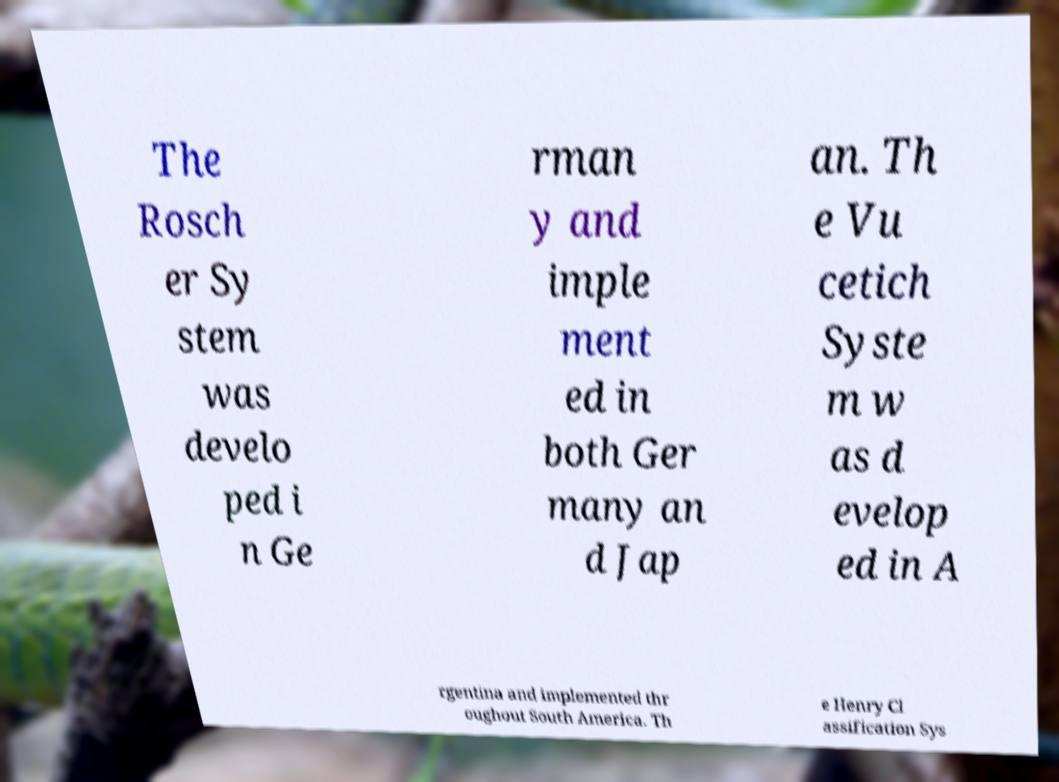Please identify and transcribe the text found in this image. The Rosch er Sy stem was develo ped i n Ge rman y and imple ment ed in both Ger many an d Jap an. Th e Vu cetich Syste m w as d evelop ed in A rgentina and implemented thr oughout South America. Th e Henry Cl assification Sys 